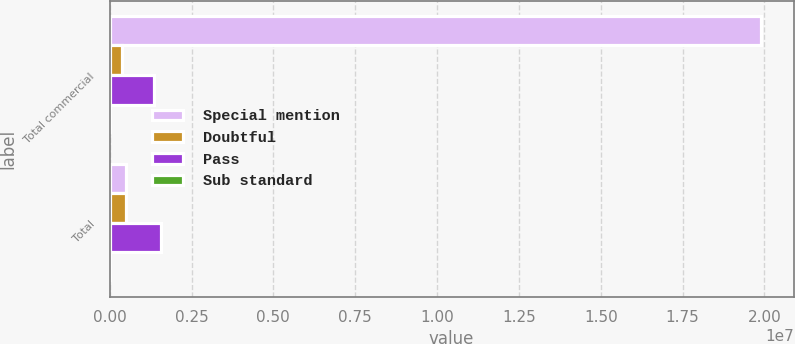Convert chart to OTSL. <chart><loc_0><loc_0><loc_500><loc_500><stacked_bar_chart><ecel><fcel>Total commercial<fcel>Total<nl><fcel>Special mention<fcel>1.9897e+07<fcel>508045<nl><fcel>Doubtful<fcel>374416<fcel>508045<nl><fcel>Pass<fcel>1.33928e+06<fcel>1.57242e+06<nl><fcel>Sub standard<fcel>4268<fcel>4268<nl></chart> 